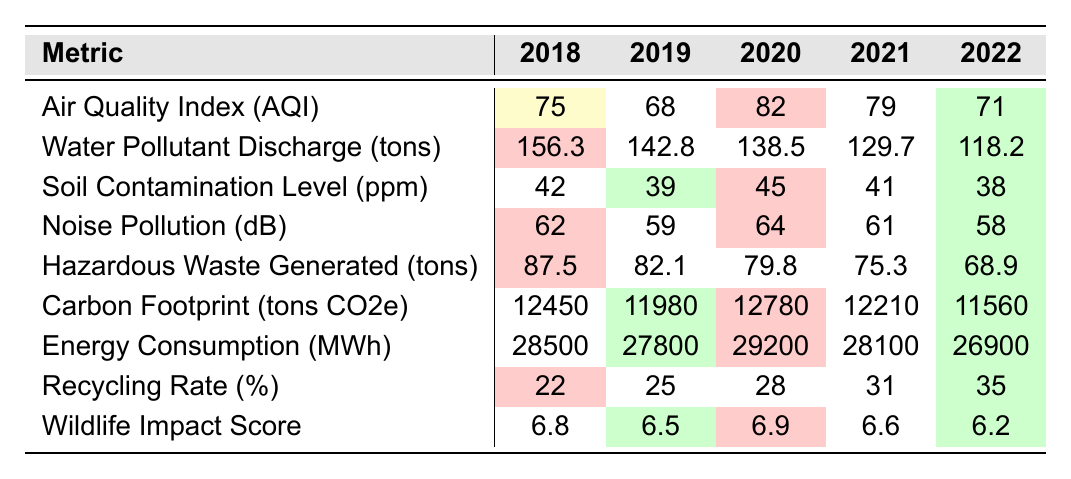What was the highest Air Quality Index (AQI) recorded in these years? The values for AQI from 2018 to 2022 are 75, 68, 82, 79, and 71. The highest among these is 82 in 2020.
Answer: 82 Which year had the lowest Water Pollutant Discharge? The Water Pollutant Discharge values for the years are 156.3, 142.8, 138.5, 129.7, and 118.2 tons. The lowest value is 118.2 tons in 2022.
Answer: 118.2 Is there a trend in Soil Contamination Level over the years? The Soil Contamination levels are 42, 39, 45, 41, and 38. It fluctuated, going down from 2018 to 2019, then up in 2020, down again in 2021, and down in 2022.
Answer: Yes What was the change in Noise Pollution from 2018 to 2022? The values for Noise Pollution are 62 dB in 2018 and 58 dB in 2022. The change is 62 - 58 = 4 dB decrease.
Answer: 4 dB decrease What was the average Carbon Footprint over these years? The Carbon Footprint values are 12450, 11980, 12780, 12210, and 11560 tons. The average is (12450 + 11980 + 12780 + 12210 + 11560) / 5 = 12258 tons.
Answer: 12258 tons In which year did the Recycling Rate exceed 30%? The Recycling Rate values are 22%, 25%, 28%, 31%, and 35%. The Recycling Rate exceeds 30% in 2021 and 2022.
Answer: 2021 and 2022 What has been the trend in Hazardous Waste Generated? The hazardous waste generated is reported as 87.5, 82.1, 79.8, 75.3, and 68.9 tons. It shows a decreasing trend over these years.
Answer: Decreasing trend What year had the highest Energy Consumption? The Energy Consumption figures are 28500, 27800, 29200, 28100, and 26900 MWh. The highest was in 2020 at 29200 MWh.
Answer: 2020 Was the Wildlife Impact Score generally improving over the years? The scores are 6.8, 6.5, 6.9, 6.6, and 6.2. It fluctuated—first decreased, then increased, then decreased again, so no consistent improvement.
Answer: No consistent improvement By how much did the Recycling Rate improve from 2018 to 2022? The Recycling Rate improved from 22% in 2018 to 35% in 2022. The increase is 35 - 22 = 13%.
Answer: 13% improvement 